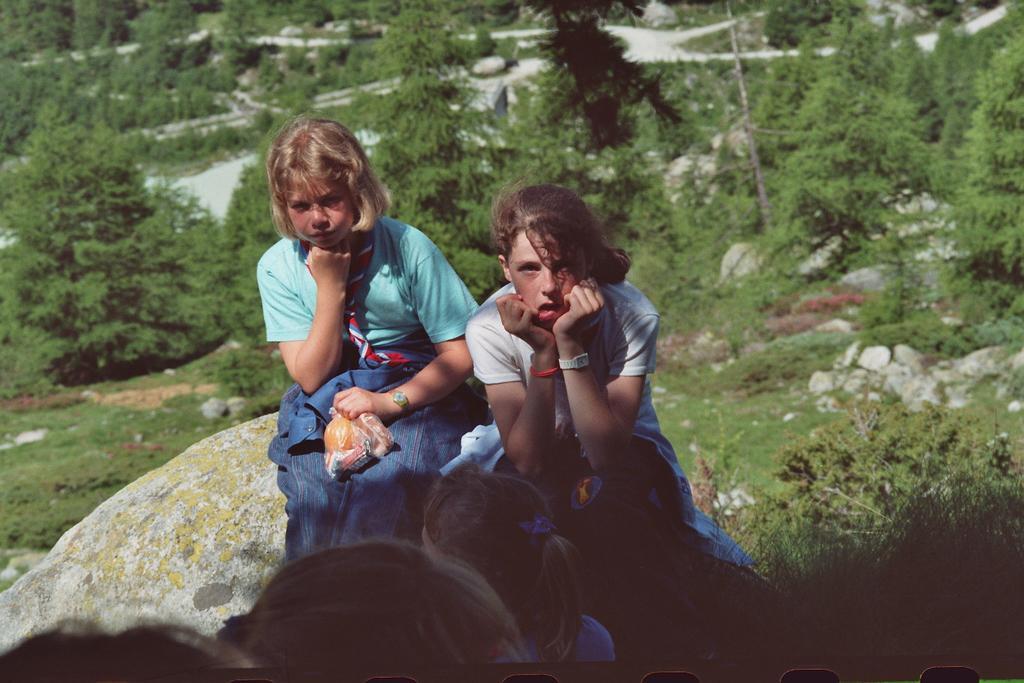How would you summarize this image in a sentence or two? At the bottom of the image few people are sitting and watching. Behind them there are some trees and grass and there are some stones and rocks. 